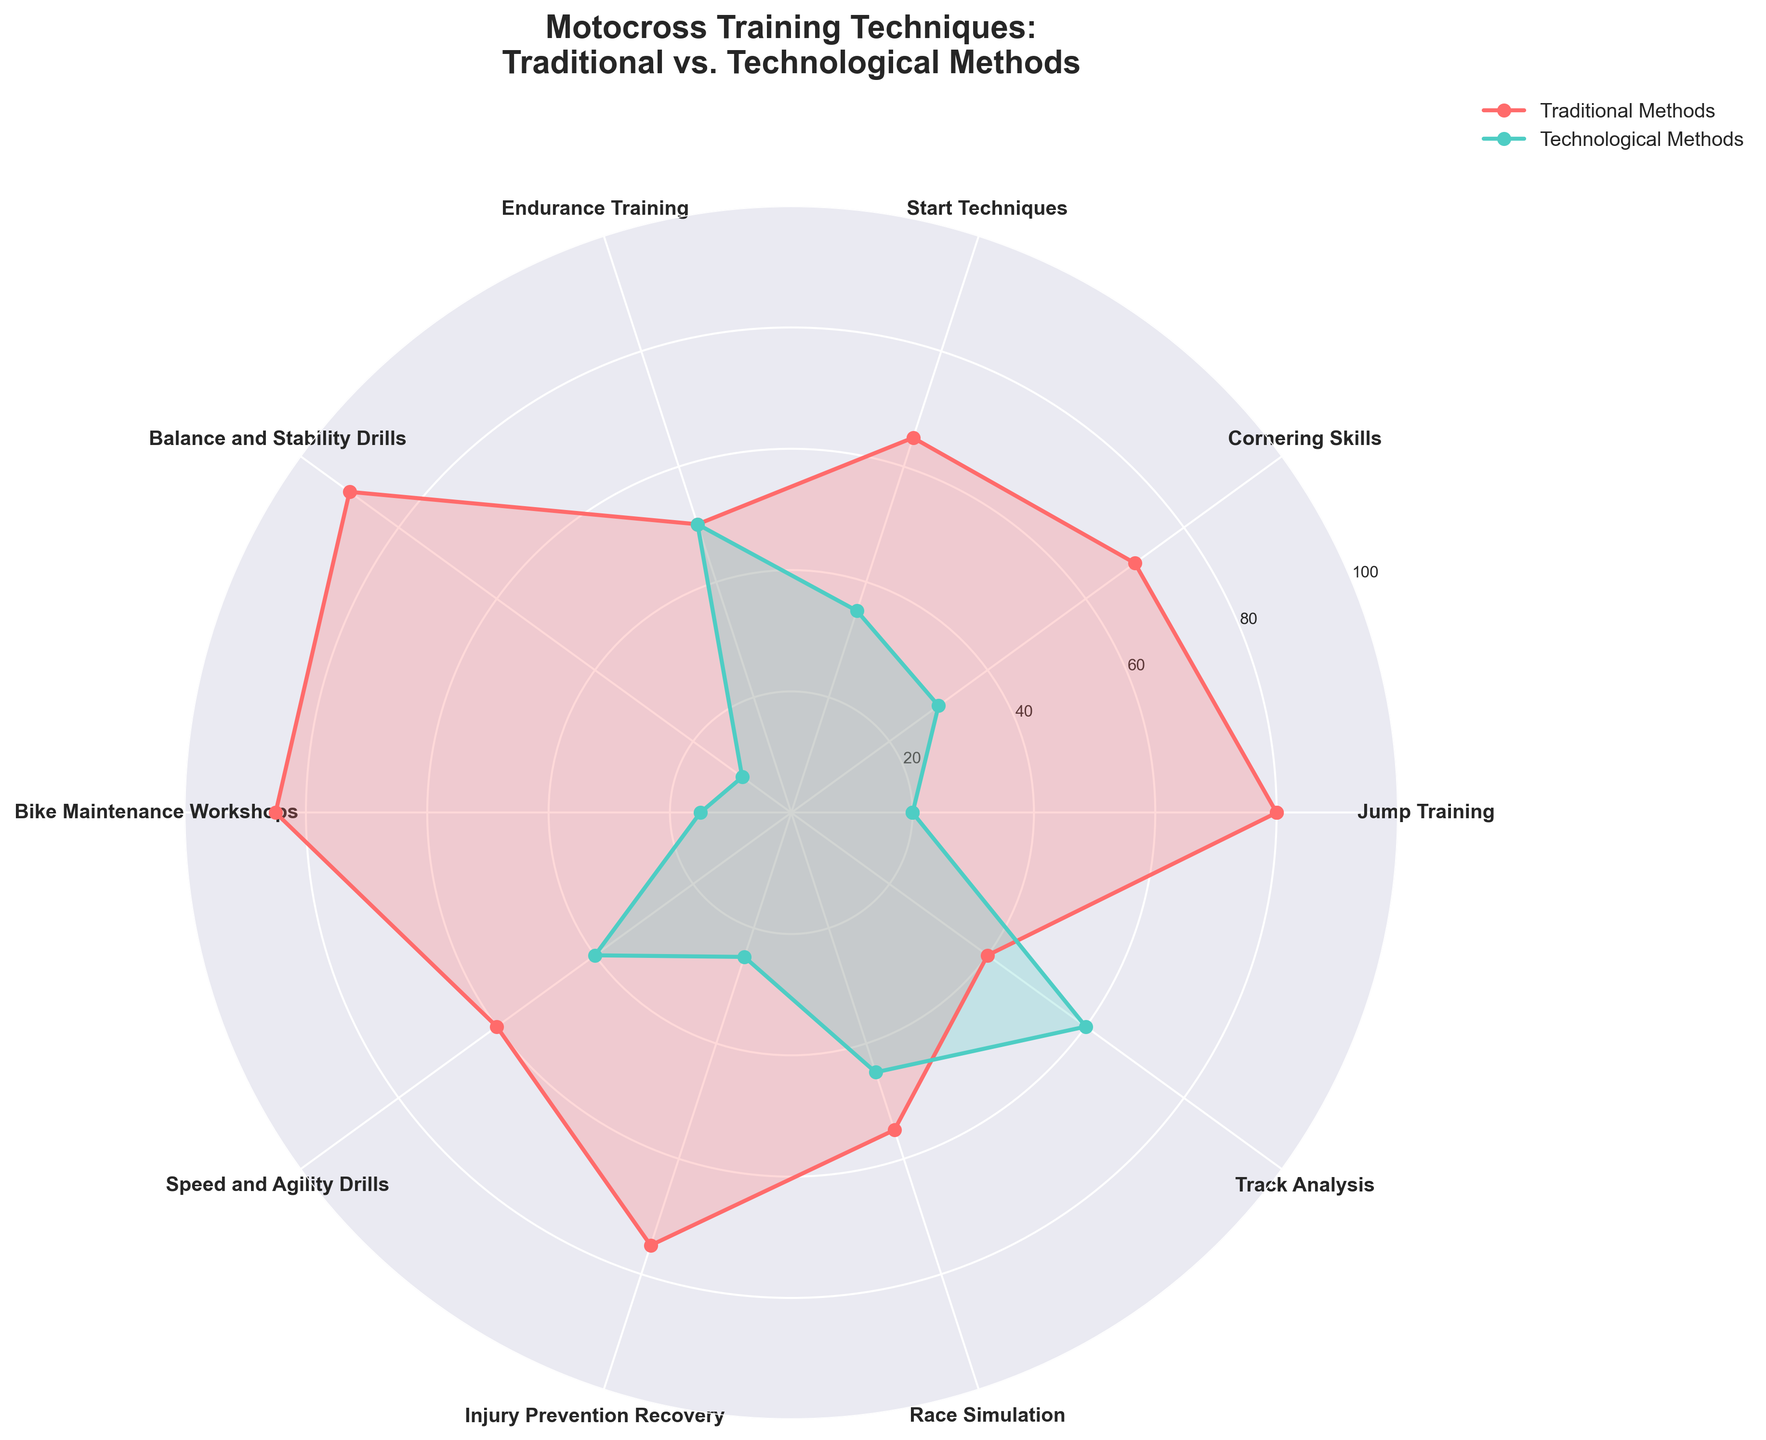What is the title of the figure? The title is generally found at the top of the plot and provides an overview of the content.
Answer: Motocross Training Techniques: Traditional vs. Technological Methods Which training technique uses the highest percentage of traditional methods? Locate the segment with the highest value on the red line representing traditional methods.
Answer: Balance and Stability Drills Which training technique relies mostly on technological methods? Find the segment where the green line (technological methods) is highest.
Answer: Track Analysis What's the total percentage of traditional methods for Jump Training and Speed and Agility Drills combined? Locate the percentages for Jump Training (80) and Speed and Agility Drills (60) on the red line and sum them: 80 + 60 = 140.
Answer: 140 Which training technique has an equal distribution between traditional and technological methods? Identify the training technique where the red line (traditional) and green line (technological) intersect at the same value.
Answer: Endurance Training How many training techniques utilize over 70% traditional methods? Count the segments where the red line exceeds the 70% y-axis mark.
Answer: 4 Which training technique has the second lowest percentage of technological methods? Find the second lowest value on the green line and identify the corresponding technique.
Answer: Bike Maintenance Workshops What's the difference between traditional and technological methods for Race Simulation? Locate the values for Race Simulation (55 for traditional, 45 for technological). Calculate the difference: 55 - 45 = 10.
Answer: 10 Among Start Techniques and Injury Prevention Recovery, which training technique uses a higher percentage of technological methods? Compare the green line values for Start Techniques (35) and Injury Prevention Recovery (25).
Answer: Start Techniques How does the usage of traditional methods for Cornering Skills compare to Bike Maintenance Workshops? Compare the red line values for Cornering Skills (70) and Bike Maintenance Workshops (85).
Answer: Bike Maintenance Workshops is higher 